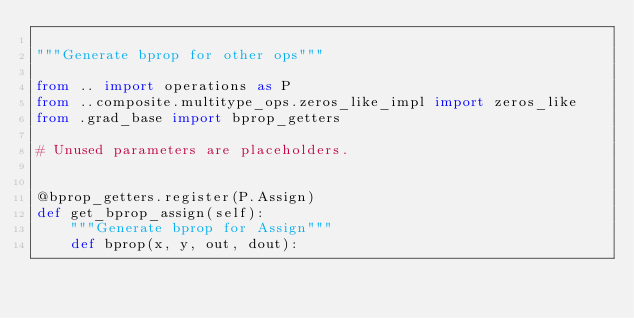<code> <loc_0><loc_0><loc_500><loc_500><_Python_>
"""Generate bprop for other ops"""

from .. import operations as P
from ..composite.multitype_ops.zeros_like_impl import zeros_like
from .grad_base import bprop_getters

# Unused parameters are placeholders.


@bprop_getters.register(P.Assign)
def get_bprop_assign(self):
    """Generate bprop for Assign"""
    def bprop(x, y, out, dout):</code> 